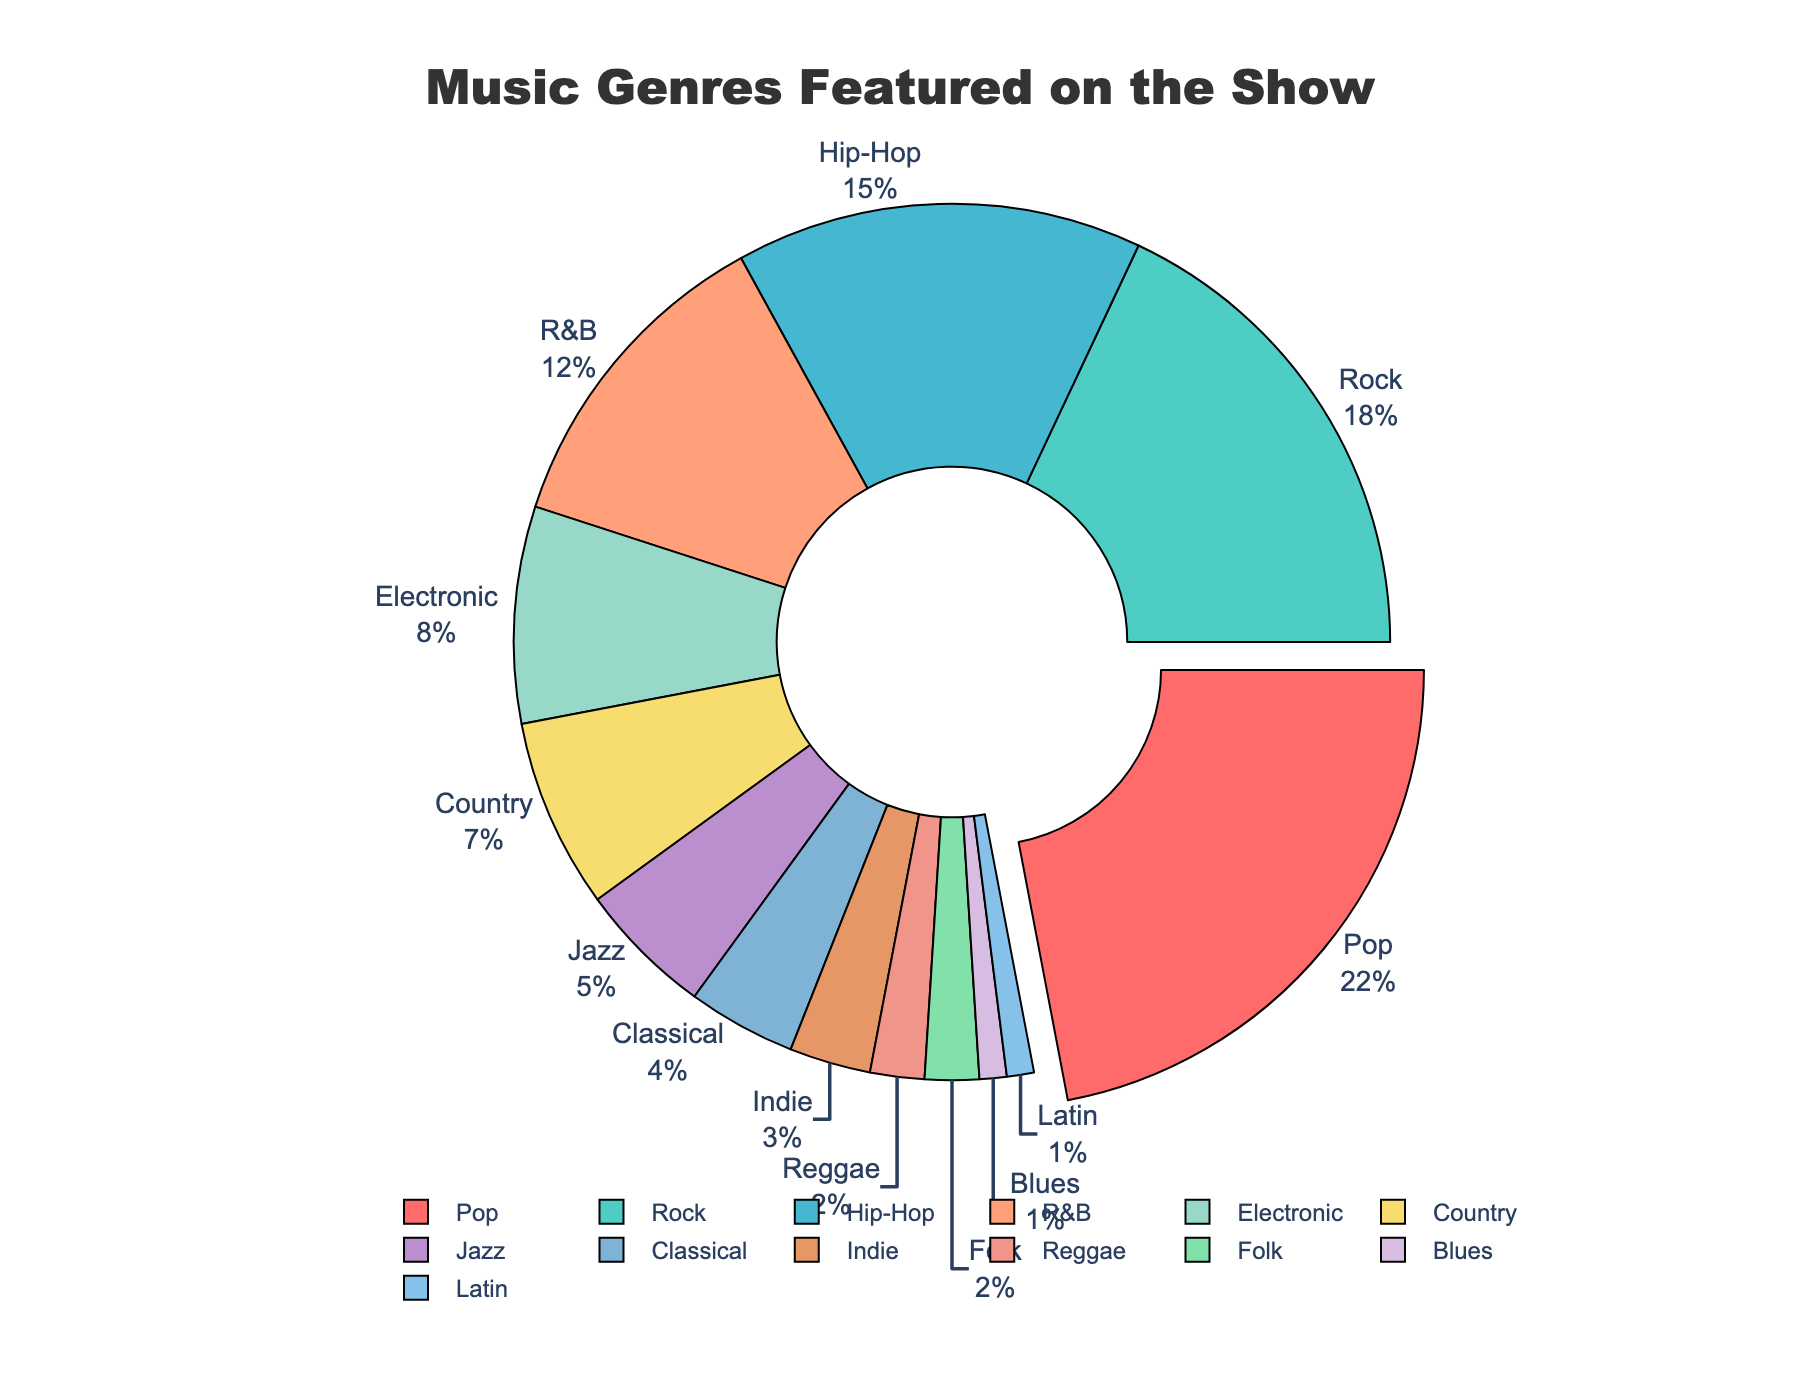What is the total percentage of Pop and Rock genres? The percentage of Pop is 22% and Rock is 18%. Adding them together gives 22% + 18% = 40%.
Answer: 40% Which genre has the smallest percentage, and what is it? The genre with the smallest percentage is Blues, with a percentage of 1%.
Answer: Blues, 1% How does the percentage of Country compare to Electronic? The percentage of Country is 7%, while Electronic is 8%. Country is 1% less than Electronic.
Answer: Country is 1% less than Electronic Which genre has the highest percentage, and what color represents it? The genre with the highest percentage is Pop, which has a percentage of 22%. It is represented by a bright red color.
Answer: Pop, bright red What is the combined percentage of genres that have less than 5% each? The genres with less than 5% are Jazz (5%), Classical (4%), Indie (3%), Reggae (2%), Folk (2%), Blues (1%), and Latin (1%). Adding these percentages: 5% + 4% + 3% + 2% + 2% + 1% + 1% = 18%.
Answer: 18% Is the percentage of Hip-Hop greater than or less than the total percentage of Classical and Indie combined? Hip-Hop has a percentage of 15%. Classical has 4% and Indie has 3%. The combined percentage of Classical and Indie is 4% + 3% = 7%. 15% is greater than 7%.
Answer: Greater What is the sum of the percentages of R&B and Country? The percentage of R&B is 12% and Country is 7%. Adding these together gives 12% + 7% = 19%.
Answer: 19% By how much does the percentage of Rock exceed that of Jazz? Rock has a percentage of 18%, while Jazz has 5%. The difference is 18% - 5% = 13%.
Answer: 13% What genres are represented by shades of blue in the chart? The shades of blue in the chart are representing Hip-Hop, Indie, Classical, and Latin.
Answer: Hip-Hop, Indie, Classical, Latin What is the difference between the percentages of the top two genres, and which are they? The top two genres are Pop (22%) and Rock (18%). The difference between them is 22% - 18% = 4%.
Answer: 4%, Pop and Rock 